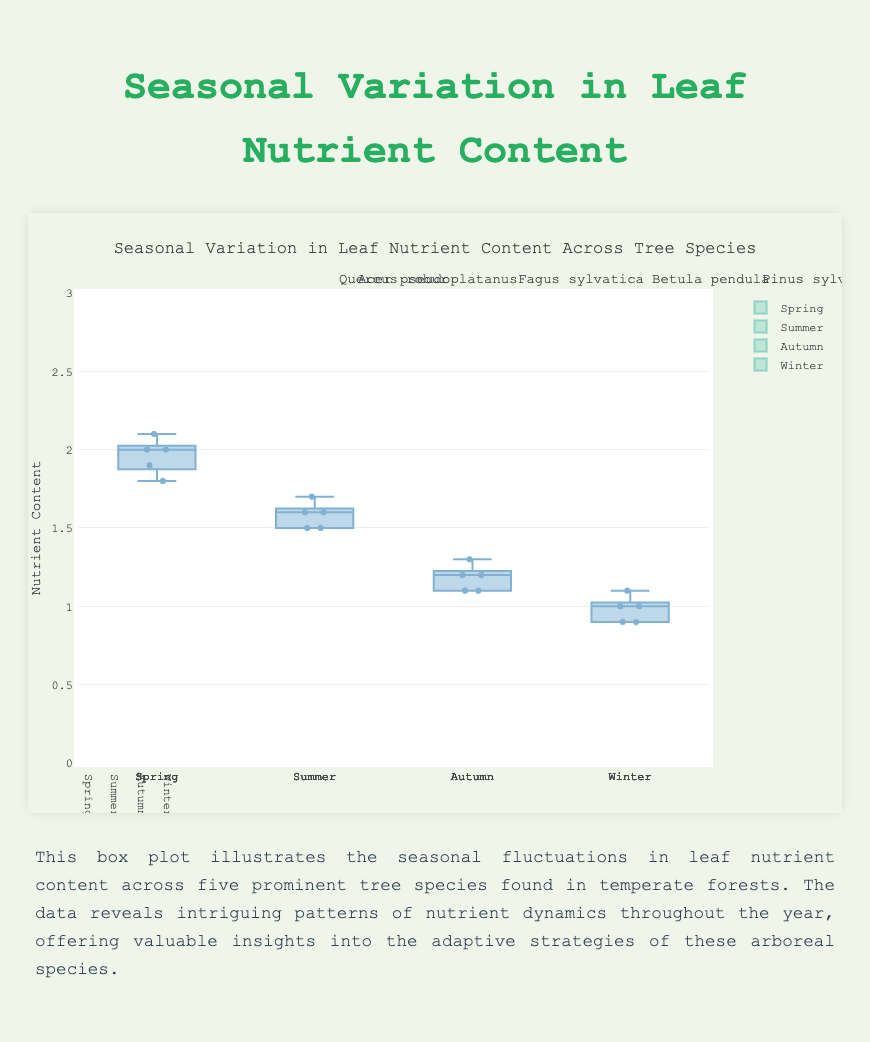Which tree species has the highest median nutrient content in Spring? To determine the tree species with the highest median nutrient content in Spring, look at the distribution of nutrient content for each species shown in the Spring box plots. The mid-line in the box represents the median. Find the highest median value.
Answer: Acer pseudoplatanus Which season shows the greatest spread in nutrient content for Quercus robur? Examine the range of the box (interquartile range) and the presence of whiskers and outliers for Quercus robur across all seasons. The season with the greatest spread has the largest difference between the lower and upper quartiles.
Answer: Spring What is the median nutrient content for Betula pendula in Summer? Locate the box plot for Betula pendula in Summer and find the median value represented by the line inside the box.
Answer: 1.9 How does the median nutrient content of Fagus sylvatica in Winter compare to that in Summer? Look at the box plots for Fagus sylvatica in Winter and Summer, compare the median values, which are represented by the lines inside the boxes.
Answer: Lower in Winter Which season has the lowest median nutrient content across all tree species? Find the median values for each season across all tree species by looking at the mid-lines in the box plots. Identify the season with the lowest overall median.
Answer: Winter What is the range of nutrient content for Pinus sylvestris in Summer? Check the box plot of Pinus sylvestris for Summer, and calculate the range by subtracting the minimum value (lower whisker) from the maximum value (upper whisker).
Answer: 1.5 - 1.7 Among the five tree species, which one has the least variation in nutrient content in Autumn? Assess the interquartile ranges (IQR) in the Autumn box plots for all five species. The species with the smallest IQR (smallest box width) has the least variation.
Answer: Pinus sylvestris What is the difference in median nutrient content between Spring and Autumn for Acer pseudoplatanus? Determine the median values for Acer pseudoplatanus in Spring and Autumn from the box plots. Subtract the Autumn median from the Spring median.
Answer: 1.0 In which season does Fagus sylvatica have the lowest nutrient content and what is the median value? Analyze the box plots for Fagus sylvatica across all seasons, and locate the one with the lowest median value.
Answer: Winter, 0.8 